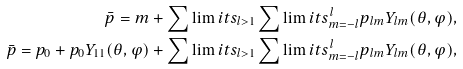Convert formula to latex. <formula><loc_0><loc_0><loc_500><loc_500>\bar { p } = m + \sum \lim i t s _ { l > 1 } \sum \lim i t s _ { m = - l } ^ { l } p _ { l m } Y _ { l m } ( \theta , \varphi ) , \\ \bar { p } = p _ { 0 } + p _ { 0 } Y _ { 1 1 } ( \theta , \varphi ) + \sum \lim i t s _ { l > 1 } \sum \lim i t s _ { m = - l } ^ { l } p _ { l m } Y _ { l m } ( \theta , \varphi ) ,</formula> 